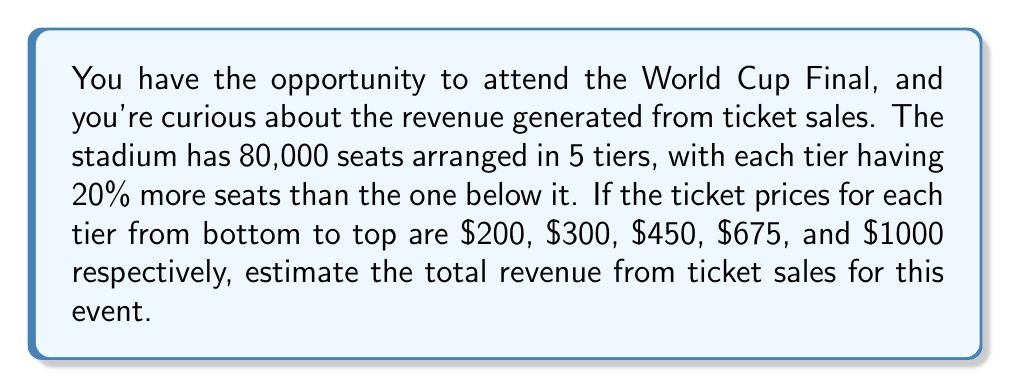Can you answer this question? Let's approach this step-by-step:

1) First, we need to determine the number of seats in each tier. Let $x$ be the number of seats in the lowest tier.

2) Given that each tier has 20% more seats than the one below it, we can express the number of seats in each tier as:
   Tier 1 (bottom): $x$
   Tier 2: $1.2x$
   Tier 3: $1.2(1.2x) = 1.44x$
   Tier 4: $1.2(1.44x) = 1.728x$
   Tier 5 (top): $1.2(1.728x) = 2.0736x$

3) The total number of seats is 80,000, so we can set up the equation:
   $$x + 1.2x + 1.44x + 1.728x + 2.0736x = 80,000$$
   $$7.4416x = 80,000$$

4) Solving for $x$:
   $$x = 80,000 / 7.4416 \approx 10,750$$

5) Now we can calculate the number of seats in each tier:
   Tier 1: 10,750
   Tier 2: 12,900
   Tier 3: 15,480
   Tier 4: 18,576
   Tier 5: 22,294

6) Multiply the number of seats in each tier by its respective ticket price:
   Tier 1: $10,750 * $200 = $2,150,000$
   Tier 2: $12,900 * $300 = $3,870,000$
   Tier 3: $15,480 * $450 = $6,966,000$
   Tier 4: $18,576 * $675 = $12,538,800$
   Tier 5: $22,294 * $1000 = $22,294,000$

7) Sum up the revenue from all tiers:
   $$2,150,000 + 3,870,000 + 6,966,000 + 12,538,800 + 22,294,000 = $47,818,800$$
Answer: $47,818,800 